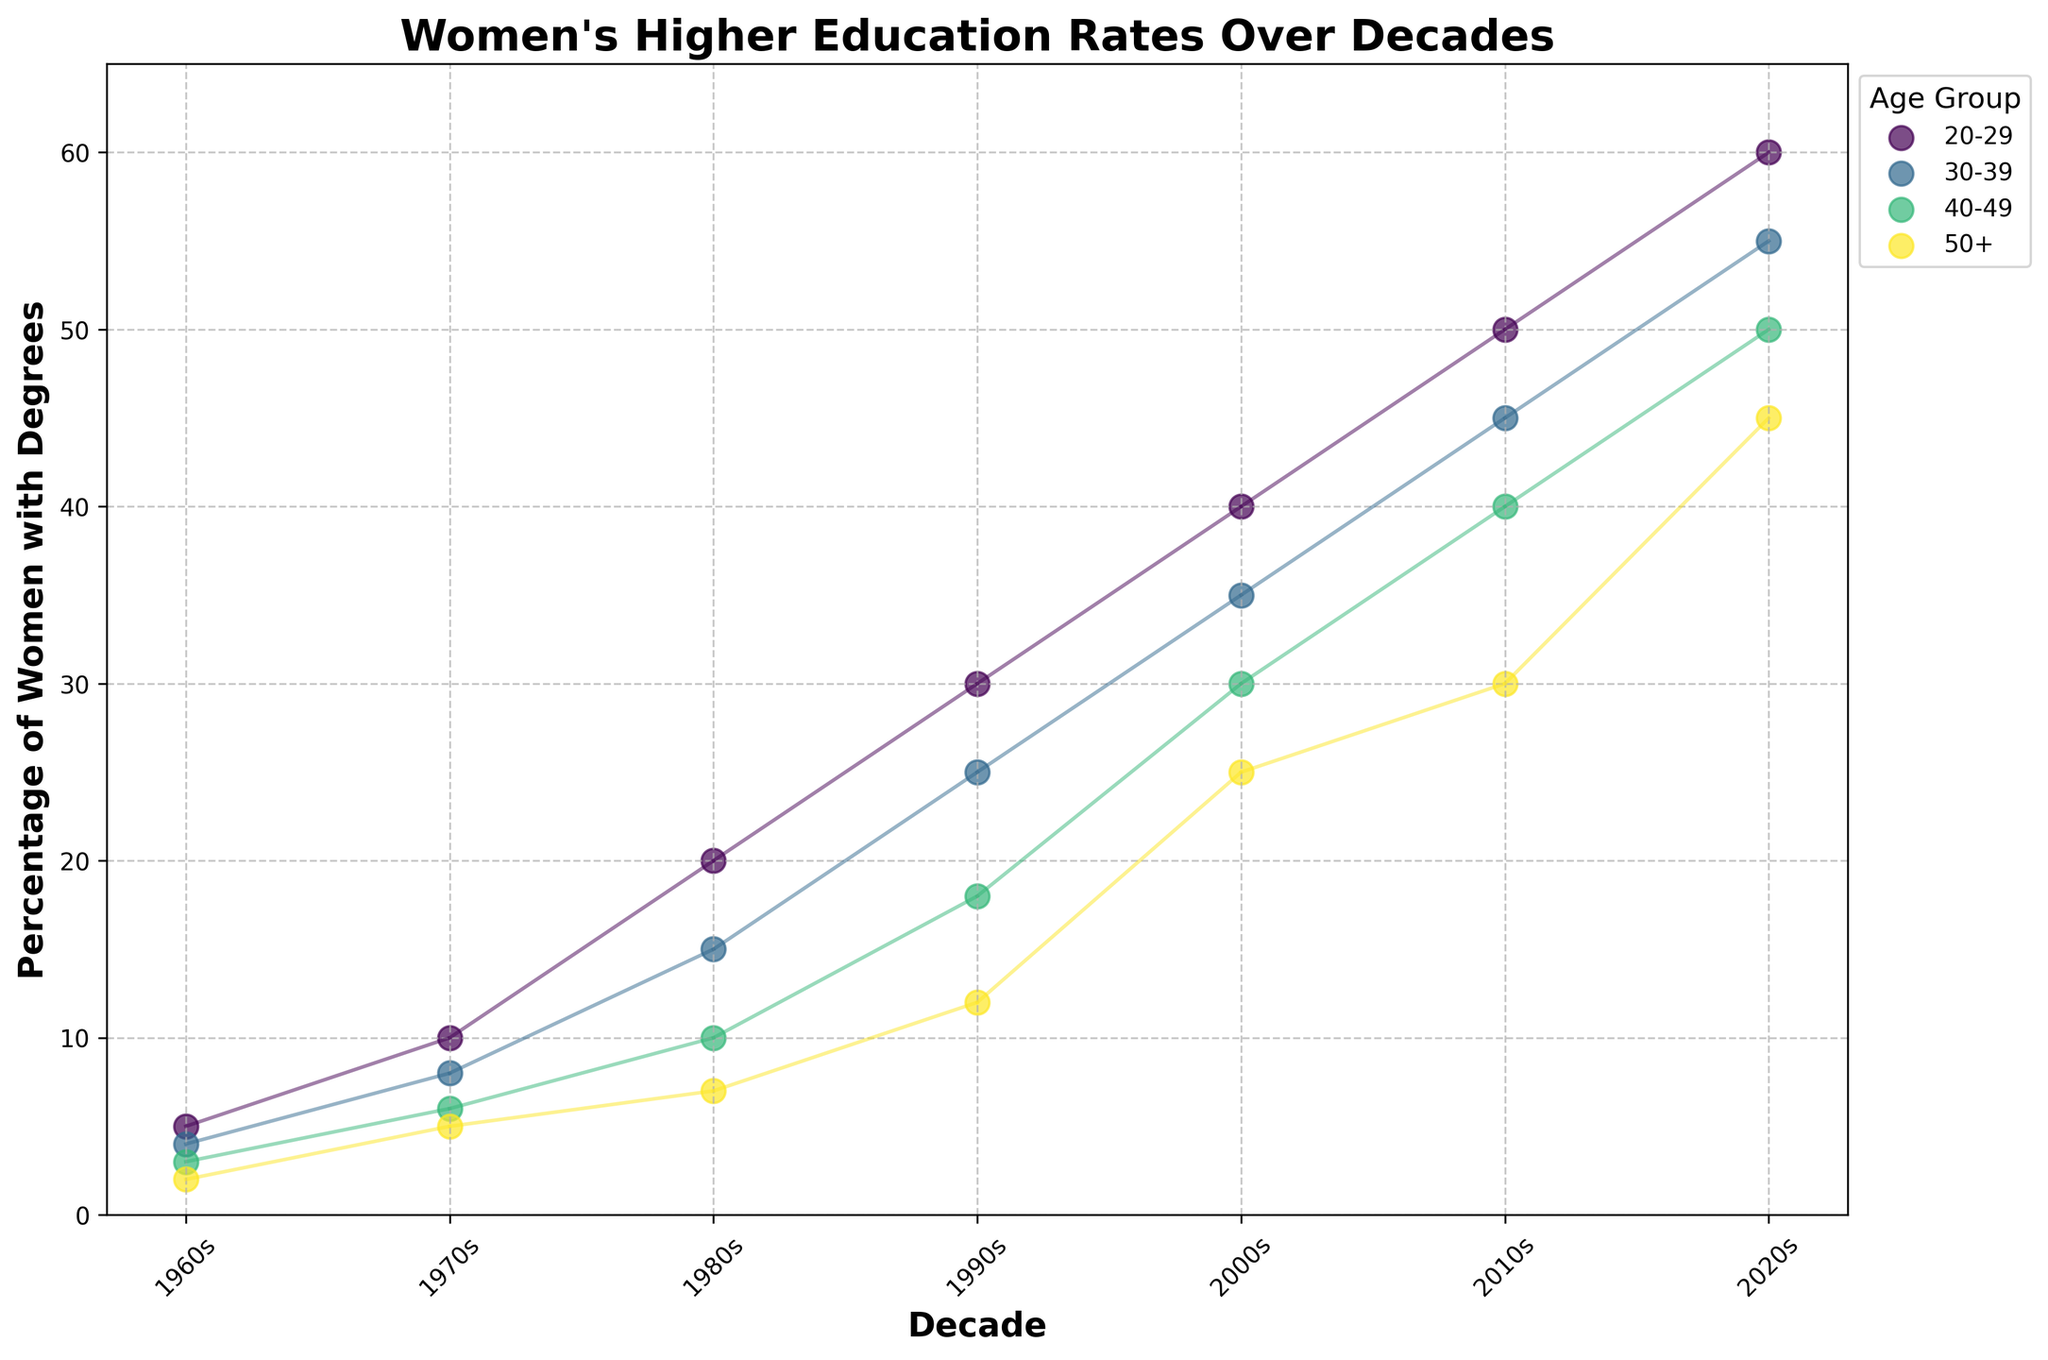What's the title of the figure? The title is the text at the top of the figure, which summarizes its main subject.
Answer: Women's Higher Education Rates Over Decades Which decade shows the highest percentage of women aged 20-29 obtaining degrees? By looking at the figure, identify the highest point along the vertical axis within the 20-29 age group series.
Answer: 2020s What is the percentage increase in women aged 30-39 obtaining degrees from the 1960s to the 2020s? Notice the 30-39 age group data points for the 1960s and 2020s, then subtract the earlier value from the later one.
Answer: 51 Which age group showed the smallest percentage increase from the 1960s to the 2020s? Calculate the difference between the 2020s and 1960s percentages for each age group, then identify the smallest increase.
Answer: 50+ What trend can be observed for the percentage of women obtaining higher education degrees over the decades? Look for the overall pattern in the data points across all age groups and decades to infer a general trend.
Answer: Increasing During which decade did women aged 40-49 see their percentage of obtaining degrees reach 30%? Find the point where the 40-49 age group data line intersects with the 30% mark along the vertical axis.
Answer: 2000s Compare the percentage change in women obtaining degrees between the 20-29 and 50+ age groups from the 1990s to the 2010s. Calculate the difference for each age group between the 1990s and 2010s, then compare the results.
Answer: 20-29 has a higher change Which decade has the closest percentage of women aged 50+ obtaining degrees to the percentage of women aged 20-29 obtaining degrees in the 1960s? Compare all decades for the 50+ age group with the 20-29 percentage in the 1960s, looking for the closest value.
Answer: 2000s How does the percentage of women aged 30-39 obtaining degrees in the 2010s compare to women aged 40-49 in the 2020s? Identify and compare the data points for women aged 30-39 in the 2010s and women aged 40-49 in the 2020s.
Answer: 2010s 30-39 is 5% lower In which decade did women aged 20-29 surpass the 30% mark in obtaining degrees? Locate the decade where the data point for the 20-29 age group first exceeds the 30% level.
Answer: 1990s 